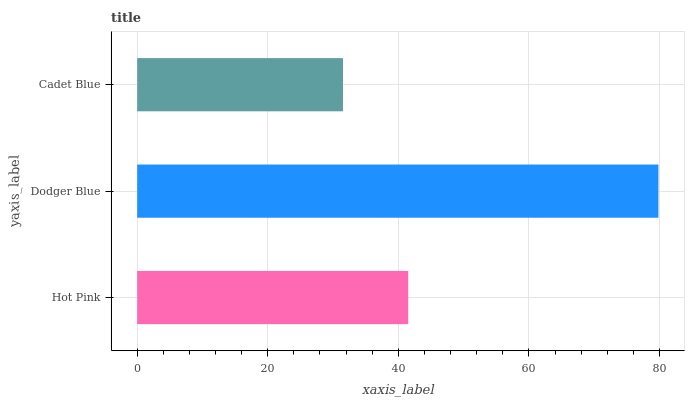Is Cadet Blue the minimum?
Answer yes or no. Yes. Is Dodger Blue the maximum?
Answer yes or no. Yes. Is Dodger Blue the minimum?
Answer yes or no. No. Is Cadet Blue the maximum?
Answer yes or no. No. Is Dodger Blue greater than Cadet Blue?
Answer yes or no. Yes. Is Cadet Blue less than Dodger Blue?
Answer yes or no. Yes. Is Cadet Blue greater than Dodger Blue?
Answer yes or no. No. Is Dodger Blue less than Cadet Blue?
Answer yes or no. No. Is Hot Pink the high median?
Answer yes or no. Yes. Is Hot Pink the low median?
Answer yes or no. Yes. Is Cadet Blue the high median?
Answer yes or no. No. Is Dodger Blue the low median?
Answer yes or no. No. 